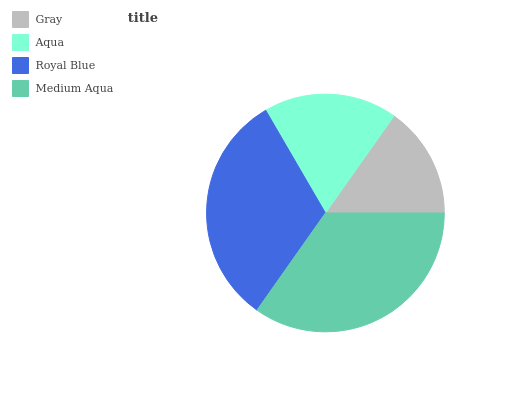Is Gray the minimum?
Answer yes or no. Yes. Is Medium Aqua the maximum?
Answer yes or no. Yes. Is Aqua the minimum?
Answer yes or no. No. Is Aqua the maximum?
Answer yes or no. No. Is Aqua greater than Gray?
Answer yes or no. Yes. Is Gray less than Aqua?
Answer yes or no. Yes. Is Gray greater than Aqua?
Answer yes or no. No. Is Aqua less than Gray?
Answer yes or no. No. Is Royal Blue the high median?
Answer yes or no. Yes. Is Aqua the low median?
Answer yes or no. Yes. Is Gray the high median?
Answer yes or no. No. Is Royal Blue the low median?
Answer yes or no. No. 